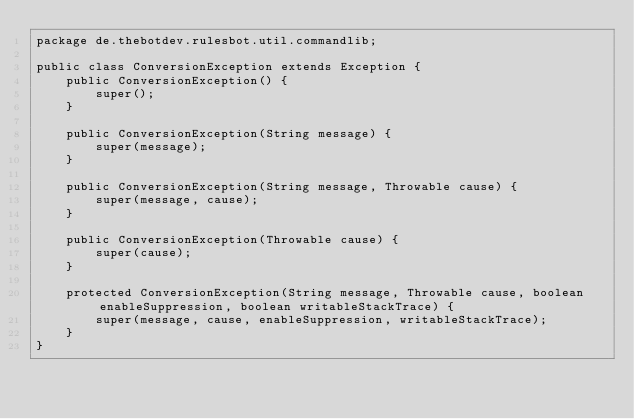Convert code to text. <code><loc_0><loc_0><loc_500><loc_500><_Java_>package de.thebotdev.rulesbot.util.commandlib;

public class ConversionException extends Exception {
    public ConversionException() {
        super();
    }

    public ConversionException(String message) {
        super(message);
    }

    public ConversionException(String message, Throwable cause) {
        super(message, cause);
    }

    public ConversionException(Throwable cause) {
        super(cause);
    }

    protected ConversionException(String message, Throwable cause, boolean enableSuppression, boolean writableStackTrace) {
        super(message, cause, enableSuppression, writableStackTrace);
    }
}
</code> 